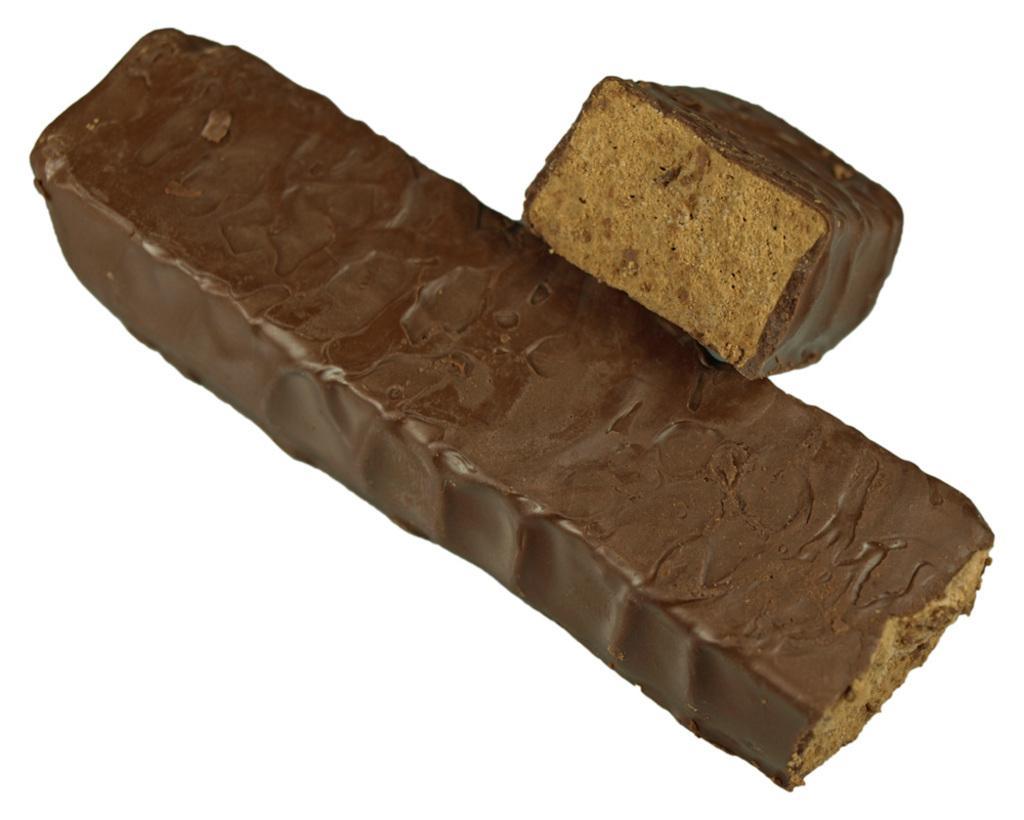Please provide a concise description of this image. In this picture we can see two pieces of a brown chocolate bar. 